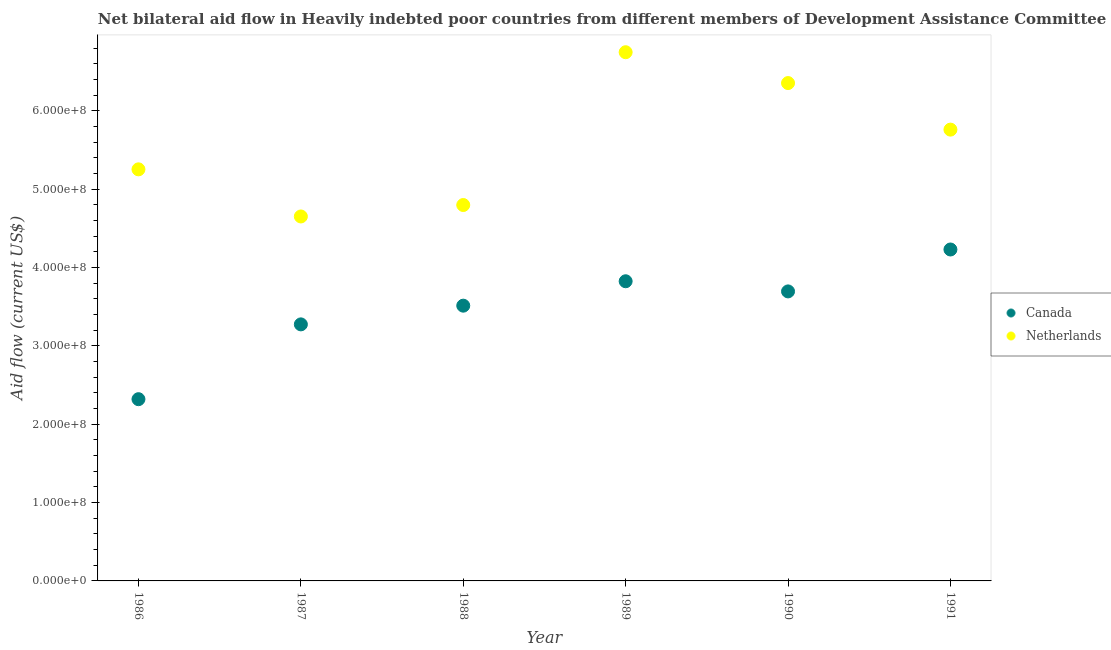How many different coloured dotlines are there?
Ensure brevity in your answer.  2. Is the number of dotlines equal to the number of legend labels?
Your answer should be compact. Yes. What is the amount of aid given by canada in 1990?
Your answer should be very brief. 3.70e+08. Across all years, what is the maximum amount of aid given by canada?
Provide a succinct answer. 4.23e+08. Across all years, what is the minimum amount of aid given by canada?
Your answer should be compact. 2.32e+08. In which year was the amount of aid given by netherlands minimum?
Provide a short and direct response. 1987. What is the total amount of aid given by netherlands in the graph?
Make the answer very short. 3.36e+09. What is the difference between the amount of aid given by canada in 1987 and that in 1988?
Ensure brevity in your answer.  -2.39e+07. What is the difference between the amount of aid given by canada in 1987 and the amount of aid given by netherlands in 1986?
Offer a terse response. -1.98e+08. What is the average amount of aid given by canada per year?
Your answer should be very brief. 3.48e+08. In the year 1991, what is the difference between the amount of aid given by netherlands and amount of aid given by canada?
Provide a short and direct response. 1.53e+08. What is the ratio of the amount of aid given by netherlands in 1986 to that in 1987?
Make the answer very short. 1.13. Is the amount of aid given by canada in 1987 less than that in 1988?
Give a very brief answer. Yes. What is the difference between the highest and the second highest amount of aid given by netherlands?
Provide a succinct answer. 3.94e+07. What is the difference between the highest and the lowest amount of aid given by netherlands?
Ensure brevity in your answer.  2.10e+08. In how many years, is the amount of aid given by canada greater than the average amount of aid given by canada taken over all years?
Offer a terse response. 4. Is the sum of the amount of aid given by netherlands in 1988 and 1990 greater than the maximum amount of aid given by canada across all years?
Your answer should be very brief. Yes. How many years are there in the graph?
Provide a succinct answer. 6. What is the difference between two consecutive major ticks on the Y-axis?
Provide a succinct answer. 1.00e+08. Are the values on the major ticks of Y-axis written in scientific E-notation?
Provide a succinct answer. Yes. Does the graph contain any zero values?
Offer a very short reply. No. Does the graph contain grids?
Offer a terse response. No. Where does the legend appear in the graph?
Offer a very short reply. Center right. What is the title of the graph?
Offer a terse response. Net bilateral aid flow in Heavily indebted poor countries from different members of Development Assistance Committee. Does "Primary education" appear as one of the legend labels in the graph?
Offer a very short reply. No. What is the label or title of the Y-axis?
Make the answer very short. Aid flow (current US$). What is the Aid flow (current US$) of Canada in 1986?
Your response must be concise. 2.32e+08. What is the Aid flow (current US$) of Netherlands in 1986?
Provide a short and direct response. 5.25e+08. What is the Aid flow (current US$) of Canada in 1987?
Your answer should be compact. 3.28e+08. What is the Aid flow (current US$) of Netherlands in 1987?
Give a very brief answer. 4.65e+08. What is the Aid flow (current US$) in Canada in 1988?
Your answer should be compact. 3.51e+08. What is the Aid flow (current US$) in Netherlands in 1988?
Ensure brevity in your answer.  4.80e+08. What is the Aid flow (current US$) of Canada in 1989?
Give a very brief answer. 3.83e+08. What is the Aid flow (current US$) in Netherlands in 1989?
Your answer should be very brief. 6.75e+08. What is the Aid flow (current US$) of Canada in 1990?
Make the answer very short. 3.70e+08. What is the Aid flow (current US$) in Netherlands in 1990?
Provide a short and direct response. 6.36e+08. What is the Aid flow (current US$) in Canada in 1991?
Your answer should be very brief. 4.23e+08. What is the Aid flow (current US$) in Netherlands in 1991?
Keep it short and to the point. 5.76e+08. Across all years, what is the maximum Aid flow (current US$) in Canada?
Provide a short and direct response. 4.23e+08. Across all years, what is the maximum Aid flow (current US$) of Netherlands?
Ensure brevity in your answer.  6.75e+08. Across all years, what is the minimum Aid flow (current US$) in Canada?
Your answer should be compact. 2.32e+08. Across all years, what is the minimum Aid flow (current US$) of Netherlands?
Give a very brief answer. 4.65e+08. What is the total Aid flow (current US$) of Canada in the graph?
Provide a succinct answer. 2.09e+09. What is the total Aid flow (current US$) in Netherlands in the graph?
Offer a terse response. 3.36e+09. What is the difference between the Aid flow (current US$) of Canada in 1986 and that in 1987?
Keep it short and to the point. -9.55e+07. What is the difference between the Aid flow (current US$) of Netherlands in 1986 and that in 1987?
Your answer should be compact. 6.02e+07. What is the difference between the Aid flow (current US$) in Canada in 1986 and that in 1988?
Ensure brevity in your answer.  -1.19e+08. What is the difference between the Aid flow (current US$) of Netherlands in 1986 and that in 1988?
Make the answer very short. 4.56e+07. What is the difference between the Aid flow (current US$) in Canada in 1986 and that in 1989?
Keep it short and to the point. -1.51e+08. What is the difference between the Aid flow (current US$) in Netherlands in 1986 and that in 1989?
Keep it short and to the point. -1.50e+08. What is the difference between the Aid flow (current US$) of Canada in 1986 and that in 1990?
Ensure brevity in your answer.  -1.38e+08. What is the difference between the Aid flow (current US$) in Netherlands in 1986 and that in 1990?
Make the answer very short. -1.10e+08. What is the difference between the Aid flow (current US$) in Canada in 1986 and that in 1991?
Your response must be concise. -1.91e+08. What is the difference between the Aid flow (current US$) in Netherlands in 1986 and that in 1991?
Give a very brief answer. -5.07e+07. What is the difference between the Aid flow (current US$) of Canada in 1987 and that in 1988?
Ensure brevity in your answer.  -2.39e+07. What is the difference between the Aid flow (current US$) in Netherlands in 1987 and that in 1988?
Your answer should be compact. -1.46e+07. What is the difference between the Aid flow (current US$) in Canada in 1987 and that in 1989?
Your answer should be compact. -5.50e+07. What is the difference between the Aid flow (current US$) of Netherlands in 1987 and that in 1989?
Provide a succinct answer. -2.10e+08. What is the difference between the Aid flow (current US$) of Canada in 1987 and that in 1990?
Offer a terse response. -4.21e+07. What is the difference between the Aid flow (current US$) in Netherlands in 1987 and that in 1990?
Ensure brevity in your answer.  -1.70e+08. What is the difference between the Aid flow (current US$) of Canada in 1987 and that in 1991?
Your answer should be compact. -9.56e+07. What is the difference between the Aid flow (current US$) in Netherlands in 1987 and that in 1991?
Give a very brief answer. -1.11e+08. What is the difference between the Aid flow (current US$) of Canada in 1988 and that in 1989?
Offer a very short reply. -3.12e+07. What is the difference between the Aid flow (current US$) of Netherlands in 1988 and that in 1989?
Your answer should be very brief. -1.95e+08. What is the difference between the Aid flow (current US$) in Canada in 1988 and that in 1990?
Make the answer very short. -1.82e+07. What is the difference between the Aid flow (current US$) of Netherlands in 1988 and that in 1990?
Provide a short and direct response. -1.56e+08. What is the difference between the Aid flow (current US$) of Canada in 1988 and that in 1991?
Give a very brief answer. -7.17e+07. What is the difference between the Aid flow (current US$) in Netherlands in 1988 and that in 1991?
Offer a very short reply. -9.63e+07. What is the difference between the Aid flow (current US$) of Canada in 1989 and that in 1990?
Make the answer very short. 1.30e+07. What is the difference between the Aid flow (current US$) in Netherlands in 1989 and that in 1990?
Make the answer very short. 3.94e+07. What is the difference between the Aid flow (current US$) in Canada in 1989 and that in 1991?
Ensure brevity in your answer.  -4.06e+07. What is the difference between the Aid flow (current US$) of Netherlands in 1989 and that in 1991?
Your answer should be compact. 9.88e+07. What is the difference between the Aid flow (current US$) of Canada in 1990 and that in 1991?
Offer a very short reply. -5.35e+07. What is the difference between the Aid flow (current US$) of Netherlands in 1990 and that in 1991?
Provide a succinct answer. 5.94e+07. What is the difference between the Aid flow (current US$) of Canada in 1986 and the Aid flow (current US$) of Netherlands in 1987?
Provide a short and direct response. -2.33e+08. What is the difference between the Aid flow (current US$) of Canada in 1986 and the Aid flow (current US$) of Netherlands in 1988?
Ensure brevity in your answer.  -2.48e+08. What is the difference between the Aid flow (current US$) in Canada in 1986 and the Aid flow (current US$) in Netherlands in 1989?
Your answer should be very brief. -4.43e+08. What is the difference between the Aid flow (current US$) in Canada in 1986 and the Aid flow (current US$) in Netherlands in 1990?
Make the answer very short. -4.04e+08. What is the difference between the Aid flow (current US$) of Canada in 1986 and the Aid flow (current US$) of Netherlands in 1991?
Provide a short and direct response. -3.44e+08. What is the difference between the Aid flow (current US$) in Canada in 1987 and the Aid flow (current US$) in Netherlands in 1988?
Provide a short and direct response. -1.52e+08. What is the difference between the Aid flow (current US$) of Canada in 1987 and the Aid flow (current US$) of Netherlands in 1989?
Offer a terse response. -3.47e+08. What is the difference between the Aid flow (current US$) in Canada in 1987 and the Aid flow (current US$) in Netherlands in 1990?
Provide a short and direct response. -3.08e+08. What is the difference between the Aid flow (current US$) in Canada in 1987 and the Aid flow (current US$) in Netherlands in 1991?
Give a very brief answer. -2.49e+08. What is the difference between the Aid flow (current US$) of Canada in 1988 and the Aid flow (current US$) of Netherlands in 1989?
Make the answer very short. -3.24e+08. What is the difference between the Aid flow (current US$) in Canada in 1988 and the Aid flow (current US$) in Netherlands in 1990?
Your response must be concise. -2.84e+08. What is the difference between the Aid flow (current US$) of Canada in 1988 and the Aid flow (current US$) of Netherlands in 1991?
Make the answer very short. -2.25e+08. What is the difference between the Aid flow (current US$) of Canada in 1989 and the Aid flow (current US$) of Netherlands in 1990?
Provide a short and direct response. -2.53e+08. What is the difference between the Aid flow (current US$) of Canada in 1989 and the Aid flow (current US$) of Netherlands in 1991?
Ensure brevity in your answer.  -1.94e+08. What is the difference between the Aid flow (current US$) in Canada in 1990 and the Aid flow (current US$) in Netherlands in 1991?
Offer a very short reply. -2.07e+08. What is the average Aid flow (current US$) in Canada per year?
Your response must be concise. 3.48e+08. What is the average Aid flow (current US$) of Netherlands per year?
Offer a terse response. 5.60e+08. In the year 1986, what is the difference between the Aid flow (current US$) in Canada and Aid flow (current US$) in Netherlands?
Offer a terse response. -2.93e+08. In the year 1987, what is the difference between the Aid flow (current US$) in Canada and Aid flow (current US$) in Netherlands?
Your answer should be compact. -1.38e+08. In the year 1988, what is the difference between the Aid flow (current US$) in Canada and Aid flow (current US$) in Netherlands?
Your answer should be compact. -1.28e+08. In the year 1989, what is the difference between the Aid flow (current US$) in Canada and Aid flow (current US$) in Netherlands?
Your answer should be compact. -2.92e+08. In the year 1990, what is the difference between the Aid flow (current US$) in Canada and Aid flow (current US$) in Netherlands?
Offer a terse response. -2.66e+08. In the year 1991, what is the difference between the Aid flow (current US$) in Canada and Aid flow (current US$) in Netherlands?
Your answer should be very brief. -1.53e+08. What is the ratio of the Aid flow (current US$) in Canada in 1986 to that in 1987?
Ensure brevity in your answer.  0.71. What is the ratio of the Aid flow (current US$) in Netherlands in 1986 to that in 1987?
Your response must be concise. 1.13. What is the ratio of the Aid flow (current US$) in Canada in 1986 to that in 1988?
Keep it short and to the point. 0.66. What is the ratio of the Aid flow (current US$) of Netherlands in 1986 to that in 1988?
Provide a short and direct response. 1.09. What is the ratio of the Aid flow (current US$) of Canada in 1986 to that in 1989?
Give a very brief answer. 0.61. What is the ratio of the Aid flow (current US$) in Netherlands in 1986 to that in 1989?
Keep it short and to the point. 0.78. What is the ratio of the Aid flow (current US$) of Canada in 1986 to that in 1990?
Provide a short and direct response. 0.63. What is the ratio of the Aid flow (current US$) in Netherlands in 1986 to that in 1990?
Your answer should be compact. 0.83. What is the ratio of the Aid flow (current US$) of Canada in 1986 to that in 1991?
Make the answer very short. 0.55. What is the ratio of the Aid flow (current US$) in Netherlands in 1986 to that in 1991?
Provide a short and direct response. 0.91. What is the ratio of the Aid flow (current US$) of Canada in 1987 to that in 1988?
Your answer should be compact. 0.93. What is the ratio of the Aid flow (current US$) in Netherlands in 1987 to that in 1988?
Make the answer very short. 0.97. What is the ratio of the Aid flow (current US$) of Canada in 1987 to that in 1989?
Make the answer very short. 0.86. What is the ratio of the Aid flow (current US$) of Netherlands in 1987 to that in 1989?
Your response must be concise. 0.69. What is the ratio of the Aid flow (current US$) in Canada in 1987 to that in 1990?
Provide a succinct answer. 0.89. What is the ratio of the Aid flow (current US$) of Netherlands in 1987 to that in 1990?
Your answer should be compact. 0.73. What is the ratio of the Aid flow (current US$) of Canada in 1987 to that in 1991?
Your response must be concise. 0.77. What is the ratio of the Aid flow (current US$) of Netherlands in 1987 to that in 1991?
Make the answer very short. 0.81. What is the ratio of the Aid flow (current US$) in Canada in 1988 to that in 1989?
Make the answer very short. 0.92. What is the ratio of the Aid flow (current US$) of Netherlands in 1988 to that in 1989?
Ensure brevity in your answer.  0.71. What is the ratio of the Aid flow (current US$) of Canada in 1988 to that in 1990?
Keep it short and to the point. 0.95. What is the ratio of the Aid flow (current US$) of Netherlands in 1988 to that in 1990?
Ensure brevity in your answer.  0.76. What is the ratio of the Aid flow (current US$) in Canada in 1988 to that in 1991?
Provide a short and direct response. 0.83. What is the ratio of the Aid flow (current US$) in Netherlands in 1988 to that in 1991?
Ensure brevity in your answer.  0.83. What is the ratio of the Aid flow (current US$) of Canada in 1989 to that in 1990?
Your answer should be very brief. 1.04. What is the ratio of the Aid flow (current US$) in Netherlands in 1989 to that in 1990?
Your response must be concise. 1.06. What is the ratio of the Aid flow (current US$) in Canada in 1989 to that in 1991?
Your response must be concise. 0.9. What is the ratio of the Aid flow (current US$) in Netherlands in 1989 to that in 1991?
Give a very brief answer. 1.17. What is the ratio of the Aid flow (current US$) of Canada in 1990 to that in 1991?
Give a very brief answer. 0.87. What is the ratio of the Aid flow (current US$) of Netherlands in 1990 to that in 1991?
Offer a very short reply. 1.1. What is the difference between the highest and the second highest Aid flow (current US$) in Canada?
Make the answer very short. 4.06e+07. What is the difference between the highest and the second highest Aid flow (current US$) in Netherlands?
Your answer should be very brief. 3.94e+07. What is the difference between the highest and the lowest Aid flow (current US$) in Canada?
Your answer should be very brief. 1.91e+08. What is the difference between the highest and the lowest Aid flow (current US$) in Netherlands?
Offer a terse response. 2.10e+08. 